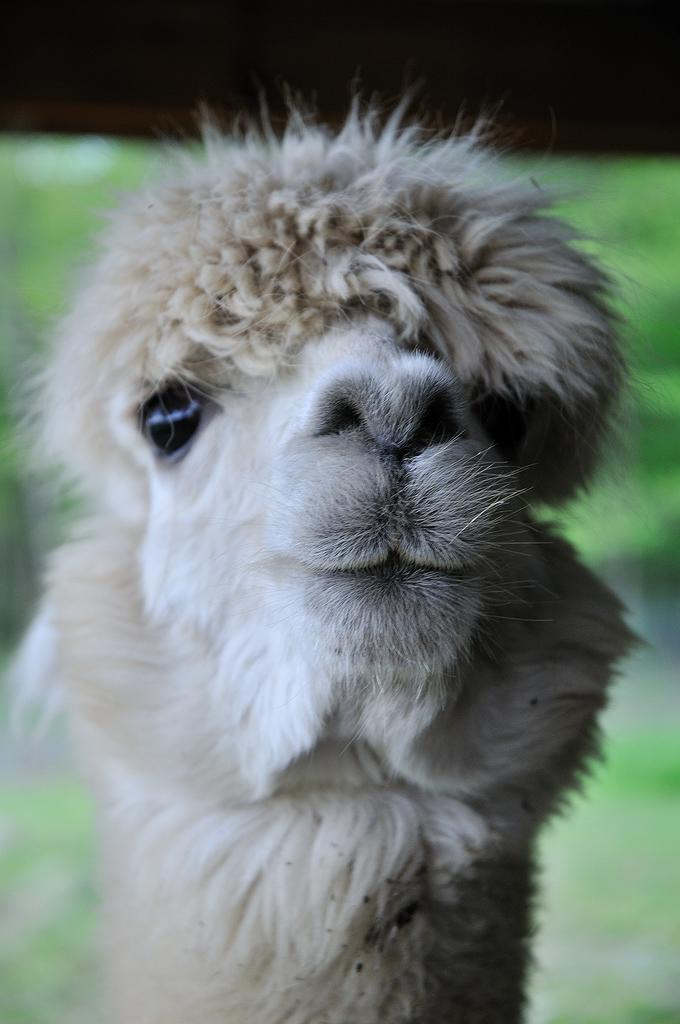What type of living creature is present in the image? There is an animal in the image. Can you describe the background of the image? The background of the image is blurry. What type of wool is being spun by the tree in the image? There is no tree or wool present in the image; it features an animal with a blurry background. 